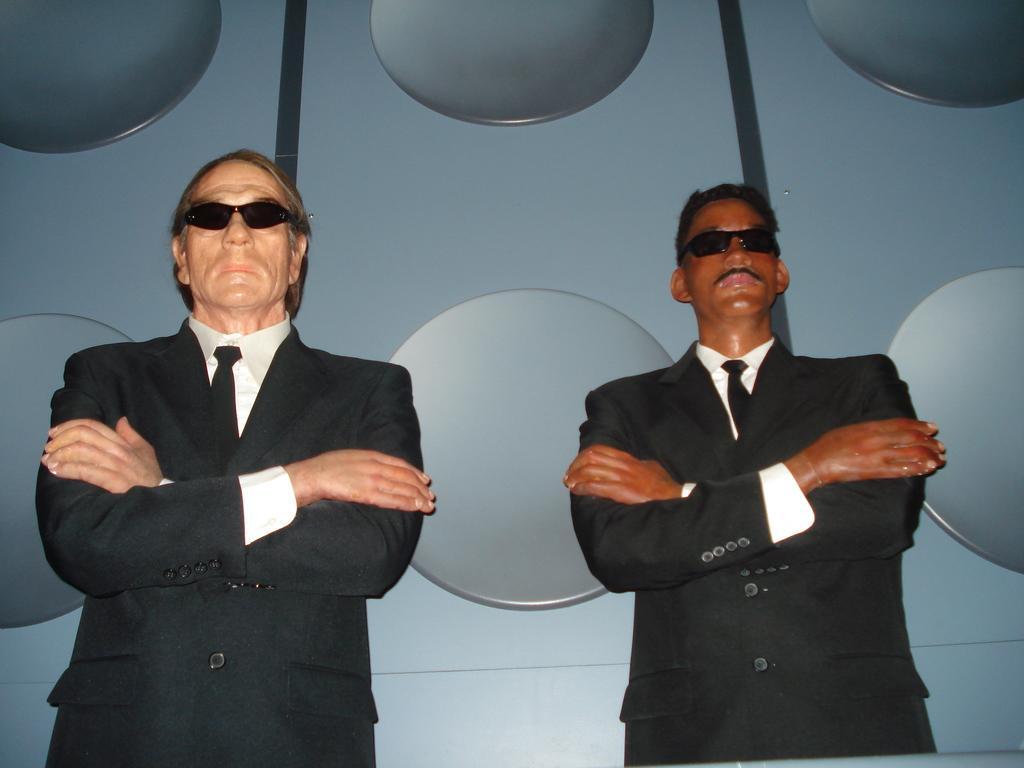Can you describe this image briefly? In the image we can see there are statues of two men standing and they are wearing formal suit and black colour sunglasses. Behind there is a wall. 